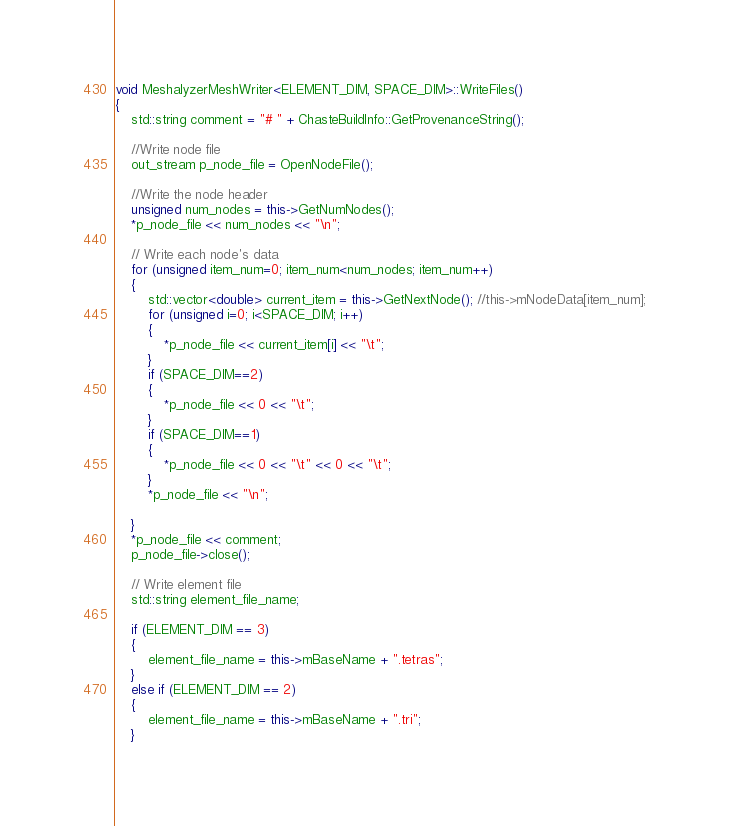Convert code to text. <code><loc_0><loc_0><loc_500><loc_500><_C++_>void MeshalyzerMeshWriter<ELEMENT_DIM, SPACE_DIM>::WriteFiles()
{
    std::string comment = "# " + ChasteBuildInfo::GetProvenanceString();

    //Write node file
    out_stream p_node_file = OpenNodeFile();

    //Write the node header
    unsigned num_nodes = this->GetNumNodes();
    *p_node_file << num_nodes << "\n";

    // Write each node's data
    for (unsigned item_num=0; item_num<num_nodes; item_num++)
    {
        std::vector<double> current_item = this->GetNextNode(); //this->mNodeData[item_num];
        for (unsigned i=0; i<SPACE_DIM; i++)
        {
            *p_node_file << current_item[i] << "\t";
        }
        if (SPACE_DIM==2)
        {
            *p_node_file << 0 << "\t";
        }
        if (SPACE_DIM==1)
        {
            *p_node_file << 0 << "\t" << 0 << "\t";
        }
        *p_node_file << "\n";

    }
    *p_node_file << comment;
    p_node_file->close();

    // Write element file
    std::string element_file_name;

    if (ELEMENT_DIM == 3)
    {
        element_file_name = this->mBaseName + ".tetras";
    }
    else if (ELEMENT_DIM == 2)
    {
        element_file_name = this->mBaseName + ".tri";
    }</code> 